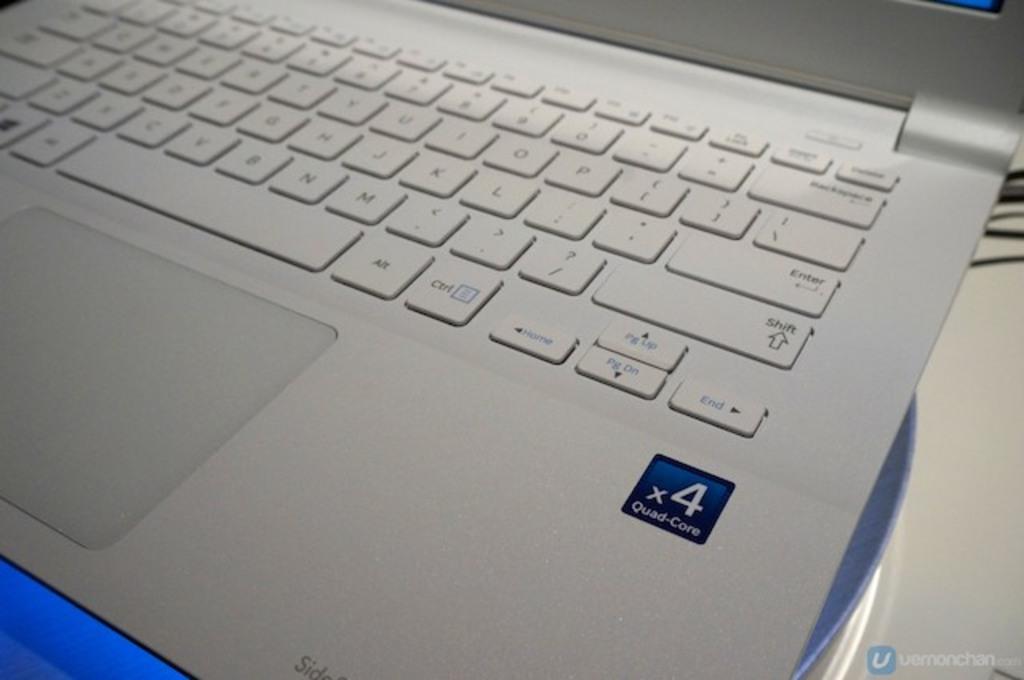What number is on the blue square on the right side of the laptop?
Provide a succinct answer. 4. What is the key just right of the spacebar?
Your answer should be very brief. Alt. 